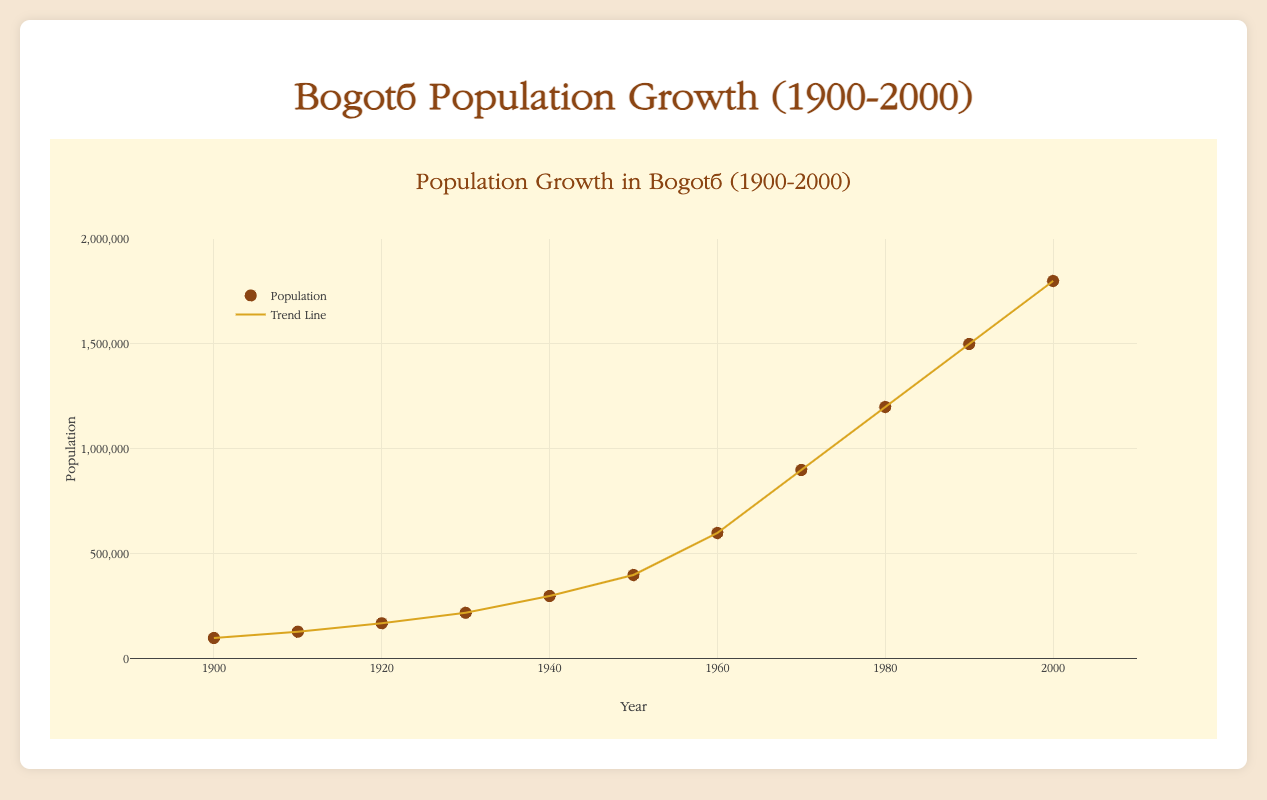What is the title of the figure? The title of the figure is usually given at the top. Here, it is clearly stated as "Population Growth in Bogotá (1900-2000)".
Answer: Population Growth in Bogotá (1900-2000) How many years are represented in the plot? To determine the number of years represented, one needs to count the unique years plotted on the x-axis or refer to the data points given. There are 11 unique years from 1900 to 2000 inclusive.
Answer: 11 What was the population of Bogotá in the year 1920? Looking at the data points on the figure, the population value for the year 1920 is marked. According to the figure, it is 170,000.
Answer: 170,000 Describe the trend in the population growth from 1900 to 2000. Observing both the scatter plot markers and the trend line, the population of Bogotá increased steadily from 100,000 in 1900 to approximately 1,800,000 in 2000. The growth appears exponential, particularly after the 1950s.
Answer: Exponential growth, especially post-1950s By how much did the population increase from 1950 to 1960? The population in 1950 is 400,000, and in 1960 it is 600,000. Subtract the earlier population value from the later one (600,000 - 400,000).
Answer: 200,000 In which decade did the population experience the highest growth? Examine the increase in population across each decade by comparing the differences. The largest increase is from 1970 (900,000) to 1980 (1,200,000), an increase of 300,000.
Answer: 1970s What are the units represented on the y-axis of the plot? The y-axis represents the population, which is measured in number of people. This information can be inferred from the population values ranging from 0 to 2,000,000.
Answer: Number of people How does the migration pattern change over the years depicted in the figure, and how might this affect population growth? The migration pattern can be identified by looking at the data and noting the increases in migration over time, which likely contributes to the population growth. Migration increases from 1,000 in 1900 to 6,000 in 2000. This positive net migration has played a significant role in the steady increase of population.
Answer: Migration increases and positively impacts population growth Compare the birth rates from 1900 and 2000. By how much have they decreased? The birth rate in 1900 is 45, and in 2000 it is 20. To find the difference, subtract the latter from the former (45 - 20).
Answer: 25 What does the color of the trend line signify in the figure? The trend line is colored gold, and it visually represents the overall trend in the population data points, indicating the direction and nature of the population growth over the years.
Answer: Represents the overall trend in population growth 